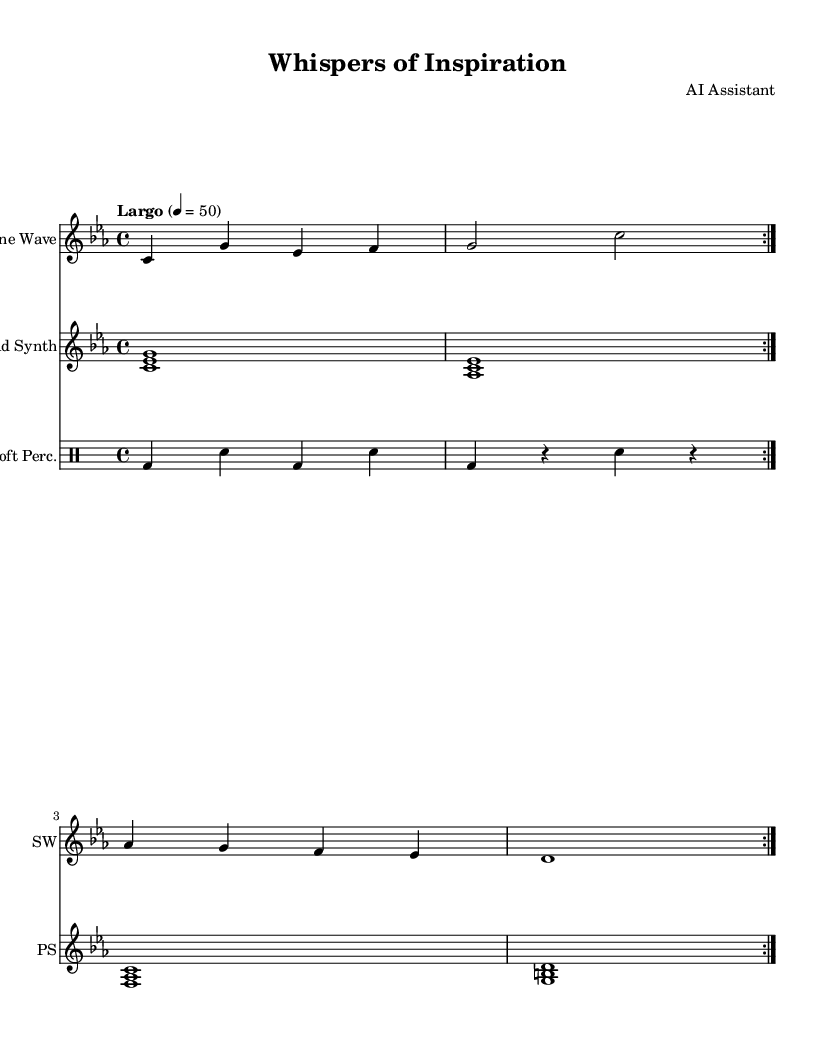What is the key signature of this music? The key signature is C minor, which typically has three flats (B, E, and A) and indicates that the music is centered around the C note. This can be identified in the initial section of the sheet music just before the staff.
Answer: C minor What is the time signature of this composition? The time signature is 4/4, which means there are four beats per measure and a quarter note receives one beat. This is indicated at the beginning of the piece and is standard for many musical compositions.
Answer: 4/4 What is the tempo marking of this piece? The tempo marking is Largo, indicating a slow tempo, typically around 40-60 beats per minute. This marking is placed above the staff at the beginning, guiding the performer on the speed of the music.
Answer: Largo How many measures are there in the sine wave synthesizer part? The sine wave synthesizer part contains four measures, as indicated by the repeated volta symbols and the layout of notes, which can be counted in sequential grouped sets on the score.
Answer: Four measures What are the instrumentation used in this piece? The instrumentation includes Sine Wave, Pad Synth, and Soft Percussion as indicated in the score with their corresponding instrument names above the staves. This diversity in instrumentation is characteristic of electronic music.
Answer: Sine Wave, Pad Synth, Soft Percussion How many times is the first section repeated in the sine wave part? The first section in the sine wave part is repeated twice, as indicated by the repeat (volta) markings in the music. This encourages continuity and provides a consistent listening experience.
Answer: Twice What type of chords are used in the pad synth section? The pad synth section uses major and minor triads, which are characterized by their three-note combinations. Each chord is built off the root, which is shown in the notation using the specified notes.
Answer: Major and minor triads 